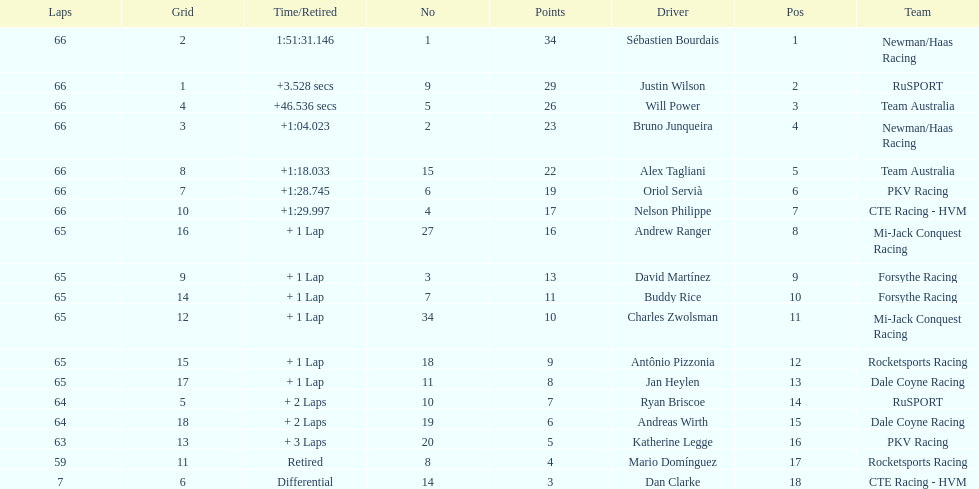Write the full table. {'header': ['Laps', 'Grid', 'Time/Retired', 'No', 'Points', 'Driver', 'Pos', 'Team'], 'rows': [['66', '2', '1:51:31.146', '1', '34', 'Sébastien Bourdais', '1', 'Newman/Haas Racing'], ['66', '1', '+3.528 secs', '9', '29', 'Justin Wilson', '2', 'RuSPORT'], ['66', '4', '+46.536 secs', '5', '26', 'Will Power', '3', 'Team Australia'], ['66', '3', '+1:04.023', '2', '23', 'Bruno Junqueira', '4', 'Newman/Haas Racing'], ['66', '8', '+1:18.033', '15', '22', 'Alex Tagliani', '5', 'Team Australia'], ['66', '7', '+1:28.745', '6', '19', 'Oriol Servià', '6', 'PKV Racing'], ['66', '10', '+1:29.997', '4', '17', 'Nelson Philippe', '7', 'CTE Racing - HVM'], ['65', '16', '+ 1 Lap', '27', '16', 'Andrew Ranger', '8', 'Mi-Jack Conquest Racing'], ['65', '9', '+ 1 Lap', '3', '13', 'David Martínez', '9', 'Forsythe Racing'], ['65', '14', '+ 1 Lap', '7', '11', 'Buddy Rice', '10', 'Forsythe Racing'], ['65', '12', '+ 1 Lap', '34', '10', 'Charles Zwolsman', '11', 'Mi-Jack Conquest Racing'], ['65', '15', '+ 1 Lap', '18', '9', 'Antônio Pizzonia', '12', 'Rocketsports Racing'], ['65', '17', '+ 1 Lap', '11', '8', 'Jan Heylen', '13', 'Dale Coyne Racing'], ['64', '5', '+ 2 Laps', '10', '7', 'Ryan Briscoe', '14', 'RuSPORT'], ['64', '18', '+ 2 Laps', '19', '6', 'Andreas Wirth', '15', 'Dale Coyne Racing'], ['63', '13', '+ 3 Laps', '20', '5', 'Katherine Legge', '16', 'PKV Racing'], ['59', '11', 'Retired', '8', '4', 'Mario Domínguez', '17', 'Rocketsports Racing'], ['7', '6', 'Differential', '14', '3', 'Dan Clarke', '18', 'CTE Racing - HVM']]} At the 2006 gran premio telmex, who finished last? Dan Clarke. 